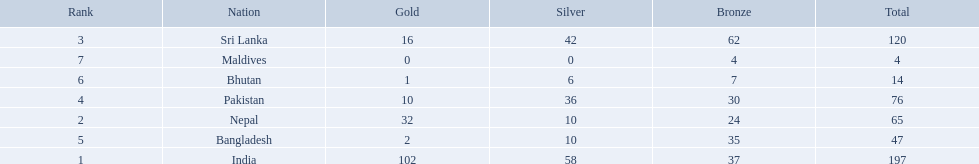What are the nations? India, Nepal, Sri Lanka, Pakistan, Bangladesh, Bhutan, Maldives. Of these, which one has earned the least amount of gold medals? Maldives. What are the totals of medals one in each country? 197, 65, 120, 76, 47, 14, 4. Which of these totals are less than 10? 4. Who won this number of medals? Maldives. 